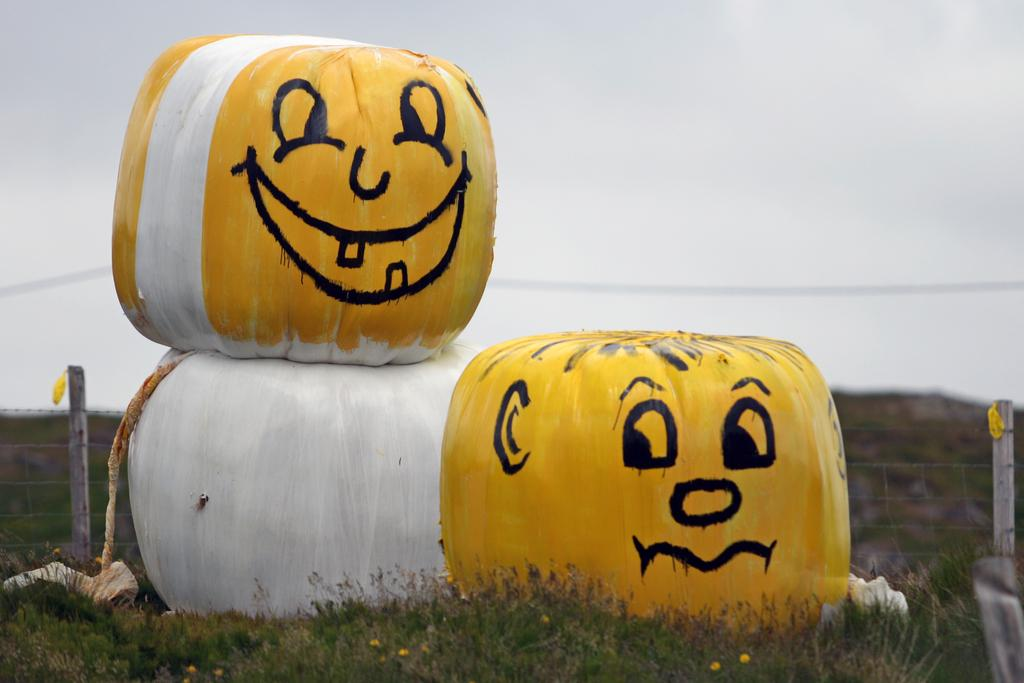How many pumpkins are in the image? There are three pumpkins in the image. Where are the pumpkins located? The pumpkins are on the grass. What colors are the pumpkins painted with? The pumpkins are painted with yellow, white, and black colors. What can be seen in the background of the image? There is a wire fence and the sky visible in the background of the image. Are there any news articles visible in the image? No, there are no news articles present in the image. Can you see any cobwebs on the pumpkins in the image? No, there are no cobwebs visible on the pumpkins in the image. 